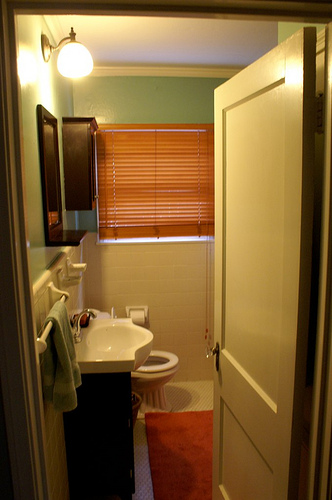What kind of room am I looking at? You are looking at a bathroom. It features essential fixtures such as a toilet, sink, and various accessories that are typical in such a space. 